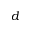<formula> <loc_0><loc_0><loc_500><loc_500>d</formula> 